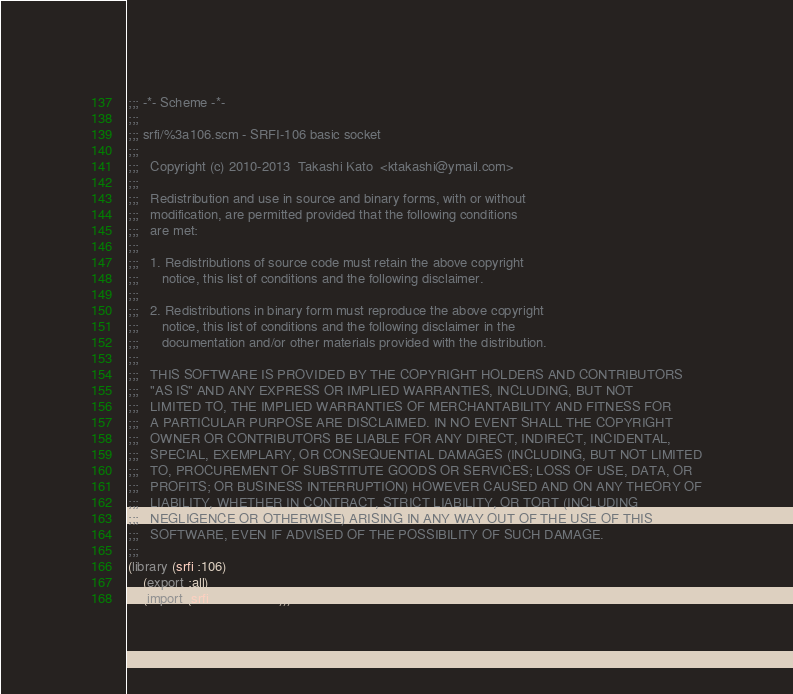Convert code to text. <code><loc_0><loc_0><loc_500><loc_500><_Scheme_>;;; -*- Scheme -*-
;;;
;;; srfi/%3a106.scm - SRFI-106 basic socket
;;;  
;;;   Copyright (c) 2010-2013  Takashi Kato  <ktakashi@ymail.com>
;;;   
;;;   Redistribution and use in source and binary forms, with or without
;;;   modification, are permitted provided that the following conditions
;;;   are met:
;;;   
;;;   1. Redistributions of source code must retain the above copyright
;;;      notice, this list of conditions and the following disclaimer.
;;;  
;;;   2. Redistributions in binary form must reproduce the above copyright
;;;      notice, this list of conditions and the following disclaimer in the
;;;      documentation and/or other materials provided with the distribution.
;;;  
;;;   THIS SOFTWARE IS PROVIDED BY THE COPYRIGHT HOLDERS AND CONTRIBUTORS
;;;   "AS IS" AND ANY EXPRESS OR IMPLIED WARRANTIES, INCLUDING, BUT NOT
;;;   LIMITED TO, THE IMPLIED WARRANTIES OF MERCHANTABILITY AND FITNESS FOR
;;;   A PARTICULAR PURPOSE ARE DISCLAIMED. IN NO EVENT SHALL THE COPYRIGHT
;;;   OWNER OR CONTRIBUTORS BE LIABLE FOR ANY DIRECT, INDIRECT, INCIDENTAL,
;;;   SPECIAL, EXEMPLARY, OR CONSEQUENTIAL DAMAGES (INCLUDING, BUT NOT LIMITED
;;;   TO, PROCUREMENT OF SUBSTITUTE GOODS OR SERVICES; LOSS OF USE, DATA, OR
;;;   PROFITS; OR BUSINESS INTERRUPTION) HOWEVER CAUSED AND ON ANY THEORY OF
;;;   LIABILITY, WHETHER IN CONTRACT, STRICT LIABILITY, OR TORT (INCLUDING
;;;   NEGLIGENCE OR OTHERWISE) ARISING IN ANY WAY OUT OF THE USE OF THIS
;;;   SOFTWARE, EVEN IF ADVISED OF THE POSSIBILITY OF SUCH DAMAGE.
;;;  
(library (srfi :106)
    (export :all)
    (import (srfi :106 socket)))</code> 